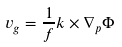<formula> <loc_0><loc_0><loc_500><loc_500>v _ { g } = \frac { 1 } { f } k \times \nabla _ { p } \Phi</formula> 